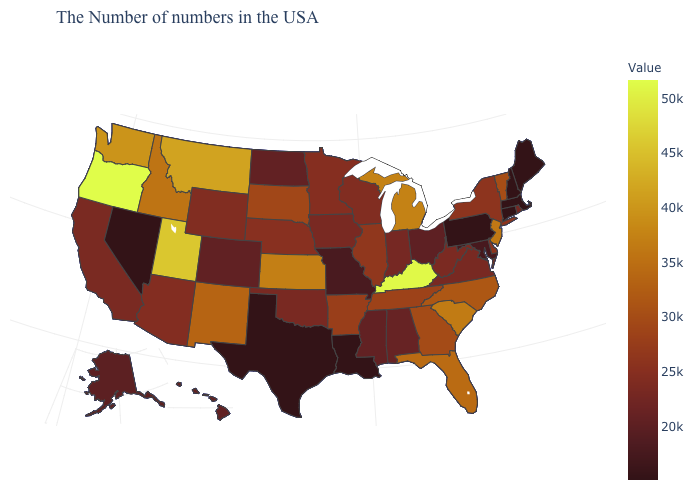Which states hav the highest value in the MidWest?
Be succinct. Michigan. Does Kansas have a higher value than Oregon?
Concise answer only. No. Does Arkansas have the lowest value in the USA?
Give a very brief answer. No. Is the legend a continuous bar?
Give a very brief answer. Yes. 